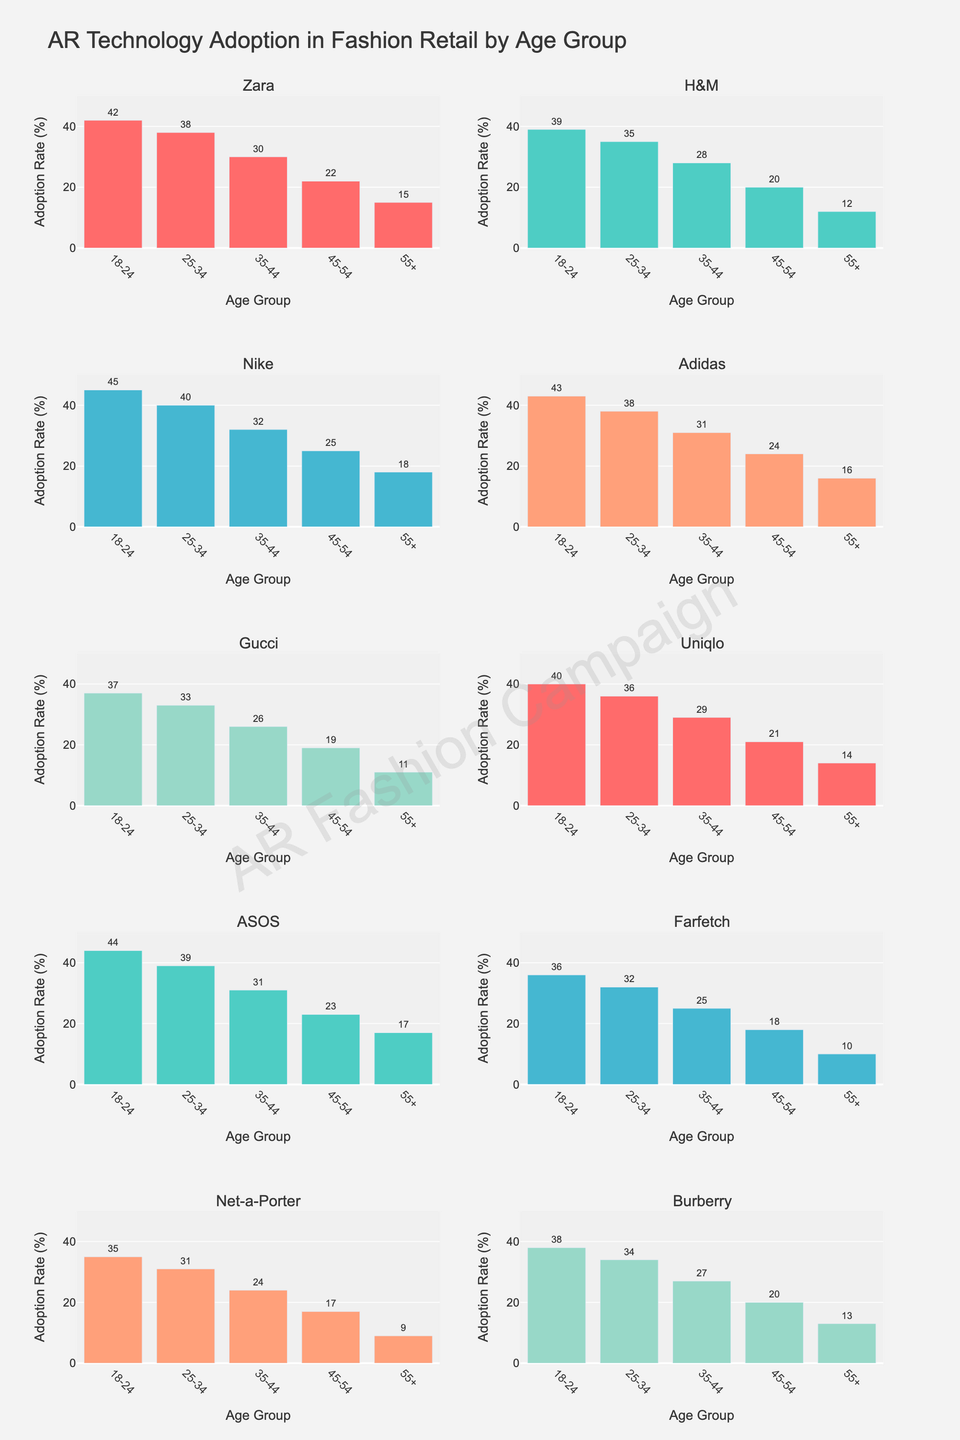What is the title of the figure? The title is displayed prominently at the top of the figure.
Answer: AR Technology Adoption in Fashion Retail by Age Group Which age group has the highest adoption rate for Nike? Look at the bar height for Nike in each age group subplot. The tallest bar will indicate the highest adoption rate for Nike.
Answer: 18-24 What are the adoption rates for ASOS in the 25-34 and 45-54 age groups? Identify the subplot for ASOS and look at the bar heights for the 25-34 and 45-54 age groups respectively.
Answer: 39 and 23 How many subplots are there in the figure? Count the number of separate subplots arranged vertically and horizontally in the figure.
Answer: 10 What is the difference in adoption rates between the 18-24 and 55+ age groups for Gucci? Find the adoption rates in the subplot for Gucci, then subtract the 55+ value from the 18-24 value.
Answer: 26 Which brand shows the least variation in adoption rates across all age groups? Identify which brand's subplot has the most uniform bar heights.
Answer: H&M What is the combined adoption rate of the 18-24 age group across all brands? Add up the 18-24 age group values for each brand's subplot. The adoption rate values of the 18-24 age group for all brands are 42, 39, 45, 43, 37, 40, 44, 36, 35, 38. Therefore, 42 + 39 + 45 + 43 + 37 + 40 + 44 + 36 + 35 + 38 = 399.
Answer: 399 Which age group shows the lowest adoption rate for Uniqlo? Look at the bar heights for Uniqlo in each age group subplot to identify the shortest bar.
Answer: 55+ How does the adoption rate of the 35-44 age group for Zara compare to that for Farfetch? Find and compare the 35-44 age group bar heights in the subplots for Zara and Farfetch.
Answer: Zara is higher than Farfetch What can be inferred about the trend in AR adoption rates across age groups? Observe the general pattern of bar heights across age groups in all subplots. The bars tend to decrease in height as age groups increase, indicating that younger age groups have higher adoption rates.
Answer: Younger age groups have higher adoption 